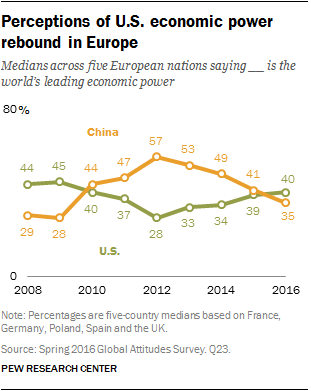Give some essential details in this illustration. China has the highest amount of data. The average of 2015 is 0.4. 